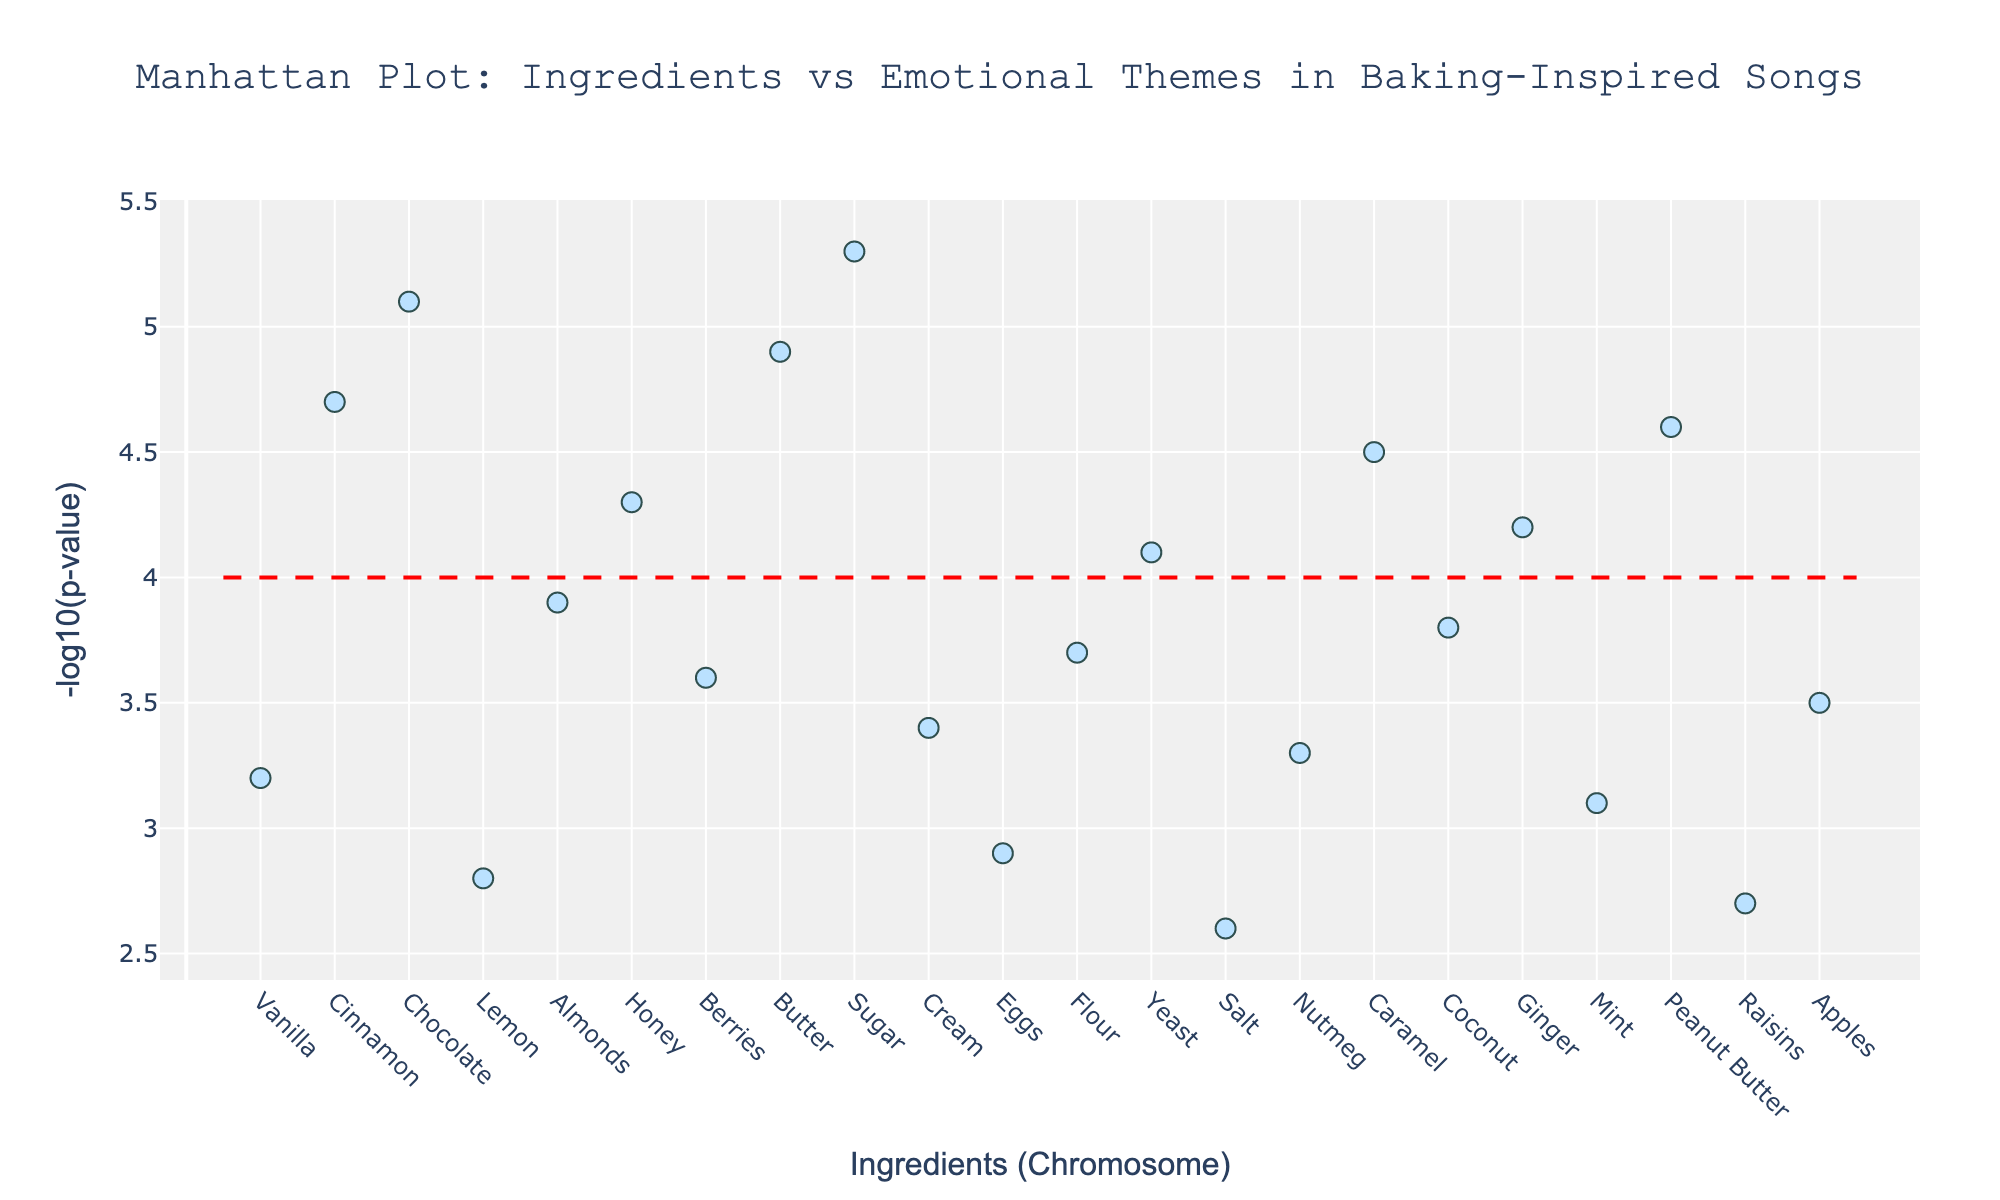What is the title of the plot? The title is usually at the top of the plot, centered and prominent. It reads: "Manhattan Plot: Ingredients vs Emotional Themes in Baking-Inspired Songs".
Answer: Manhattan Plot: Ingredients vs Emotional Themes in Baking-Inspired Songs What is the y-axis measuring in the plot? The y-axis is labeled "-log10(p-value)", which means it is depicting the negative logarithm (base 10) of the p-value for each ingredient.
Answer: -log10(p-value) Which ingredient is associated with the highest -log10(p-value)? From the plot, the highest point on the y-axis corresponds to an ingredient. The highest -log10(p-value) is around 5.3 which is the ingredient "Sugar".
Answer: Sugar How many ingredients have a -log10(p-value) greater than 4? To answer this, count all points above the red threshold line at y=4. These points represent the ingredients Cinnamon, Chocolate, Honey, Butter, Yeast, Caramel, Ginger, and Peanut Butter. There are 8 such ingredients.
Answer: 8 Which emotional theme is associated with the ingredient that has the highest -log10(p-value)? First, identify the ingredient with the highest -log10(p-value), which is Sugar. Then, check its corresponding emotional theme, which is "Happiness".
Answer: Happiness What is the -log10(p-value) for the ingredient "Chocolate"? Locate "Chocolate" on the x-axis and refer to its y value. "Chocolate" is on Chromosome 3 at the y value of 5.1.
Answer: 5.1 Among the ingredients: Vanilla, Cinnamon, Flour, and Salt, which one has the lowest -log10(p-value)? Compare the -log10(p-values) for these ingredients: Vanilla (3.2), Cinnamon (4.7), Flour (3.7), Salt (2.6). Salt has the lowest -log10(p-value) at 2.6.
Answer: Salt Which ingredients are associated with a y-value between 4.0 and 4.5? Identify and list all points whose -log10(p) values fall within 4.0 to 4.5: Cinnamon (4.7), Honey (4.3), Yeast (4.1), Ginger (4.2). Among these, only Honey, Yeast and Ginger have values exactly between 4.0 and 4.5.
Answer: Honey, Yeast, Ginger What observation can you make about the emotional themes Comfort and Indulgence in the plot? Look for the ingredients "Cinnamon" (Comfort) and "Butter" (Indulgence) on the plot. Observe their positions on the y-axis. Both themes are associated with high -log10(p-values), 4.7 and 4.9 respectively, indicating strong associations.
Answer: Both have high -log10(p-values) Which ingredient has a -log10(p-value) closest to 3.5, and what is its associated emotional theme? Identify and compare the y-values to see which is closest to 3.5: Berries (3.6) and Apples (3.5) are the closest. Apples is associated with 3.5 exactly and has the theme "Wholesome".
Answer: Apples, Wholesome 